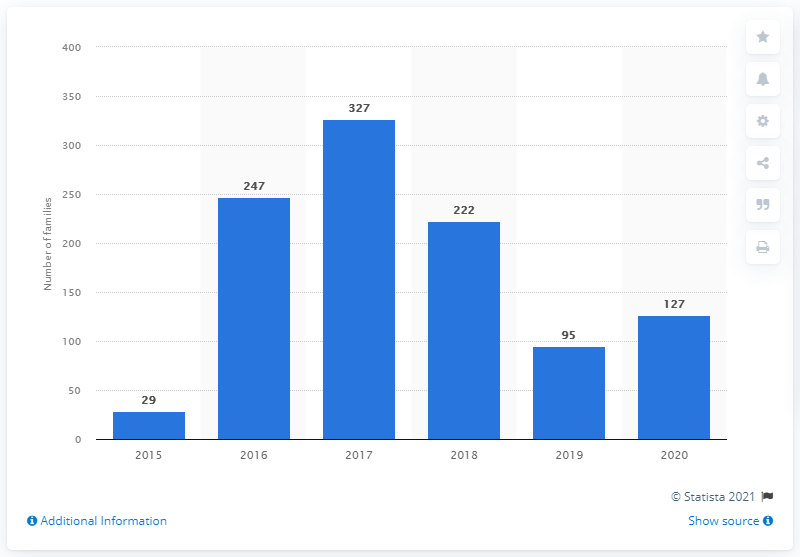Give some essential details in this illustration. In the previous year, there were 95 newly discovered ransomware families. There were 127 newly discovered ransomware families in the most recent measured period. 